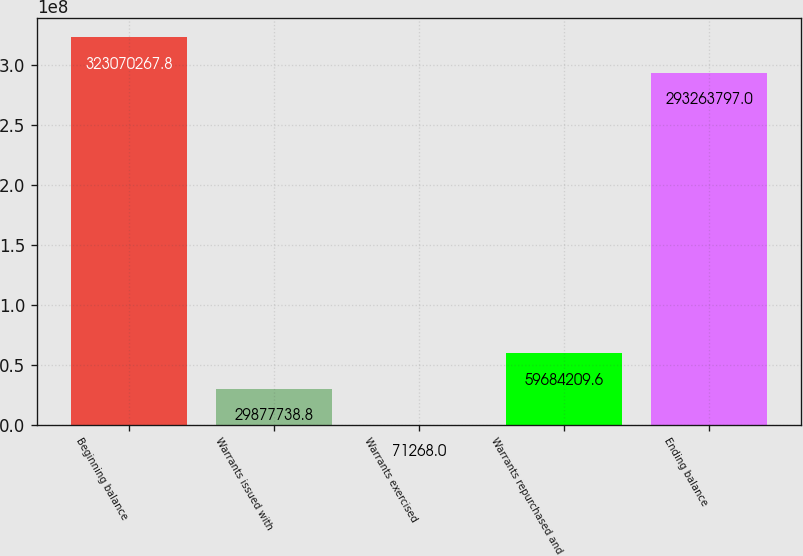<chart> <loc_0><loc_0><loc_500><loc_500><bar_chart><fcel>Beginning balance<fcel>Warrants issued with<fcel>Warrants exercised<fcel>Warrants repurchased and<fcel>Ending balance<nl><fcel>3.2307e+08<fcel>2.98777e+07<fcel>71268<fcel>5.96842e+07<fcel>2.93264e+08<nl></chart> 